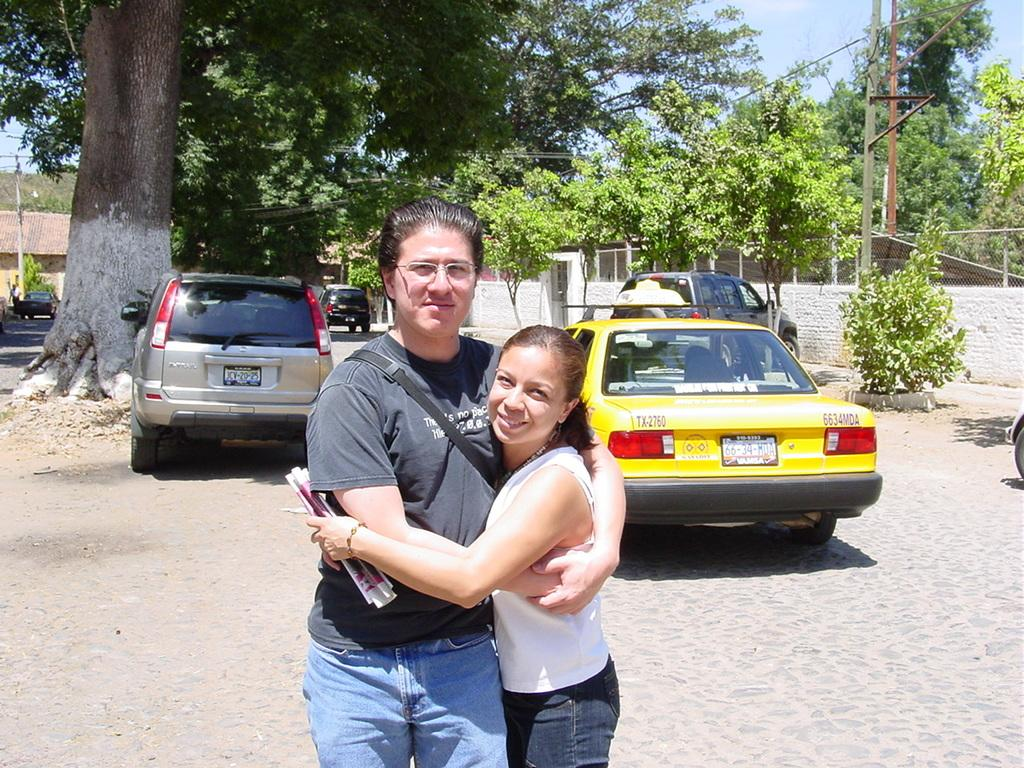<image>
Create a compact narrative representing the image presented. Two people hug each other behind taxi number TX-2760. 